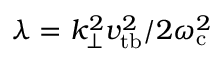<formula> <loc_0><loc_0><loc_500><loc_500>\lambda = k _ { \perp } ^ { 2 } v _ { t b } ^ { 2 } / 2 \omega _ { c } ^ { 2 }</formula> 